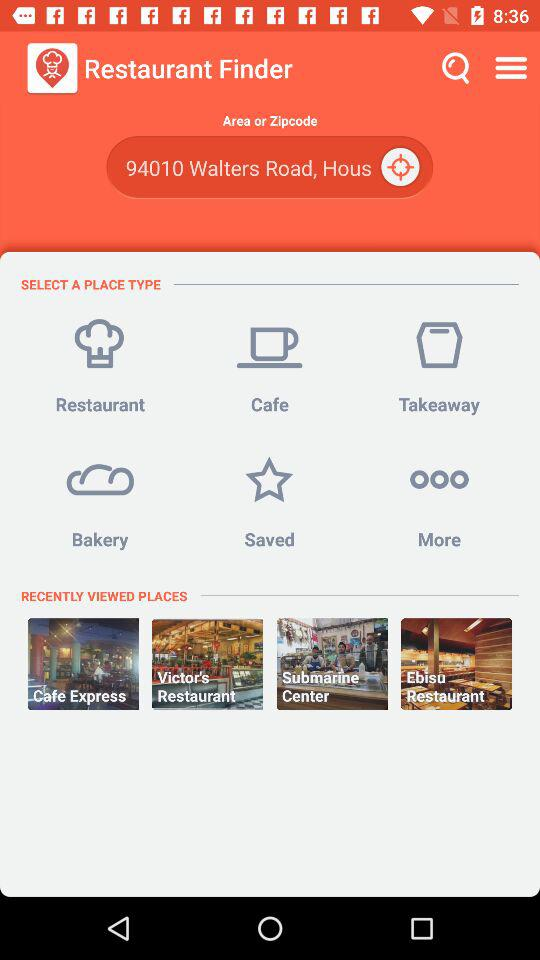What is the area or zipcode? The area or zip code is 94010 Walters Road, Hous. 